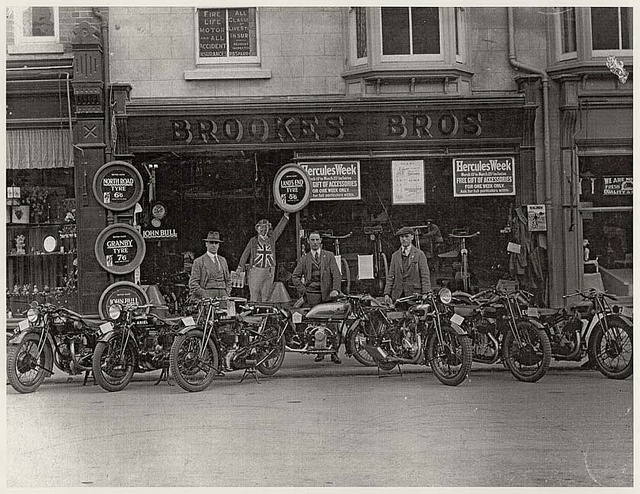Describe the objects in this image and their specific colors. I can see motorcycle in ivory, black, gray, and darkgray tones, motorcycle in ivory, black, gray, and darkgray tones, motorcycle in ivory, black, gray, and darkgray tones, motorcycle in ivory, black, gray, and darkgray tones, and motorcycle in ivory, black, gray, and darkgray tones in this image. 